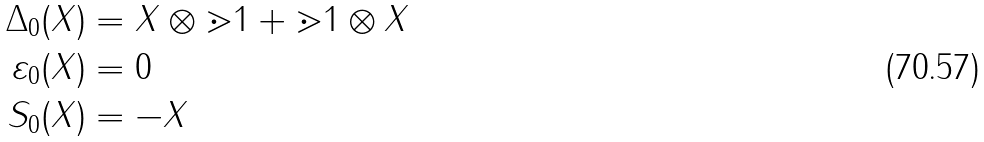Convert formula to latex. <formula><loc_0><loc_0><loc_500><loc_500>\Delta _ { 0 } ( X ) & = X \otimes \mathbb { m } { 1 } + \mathbb { m } { 1 } \otimes X \\ \varepsilon _ { 0 } ( X ) & = 0 \\ S _ { 0 } ( X ) & = - X</formula> 